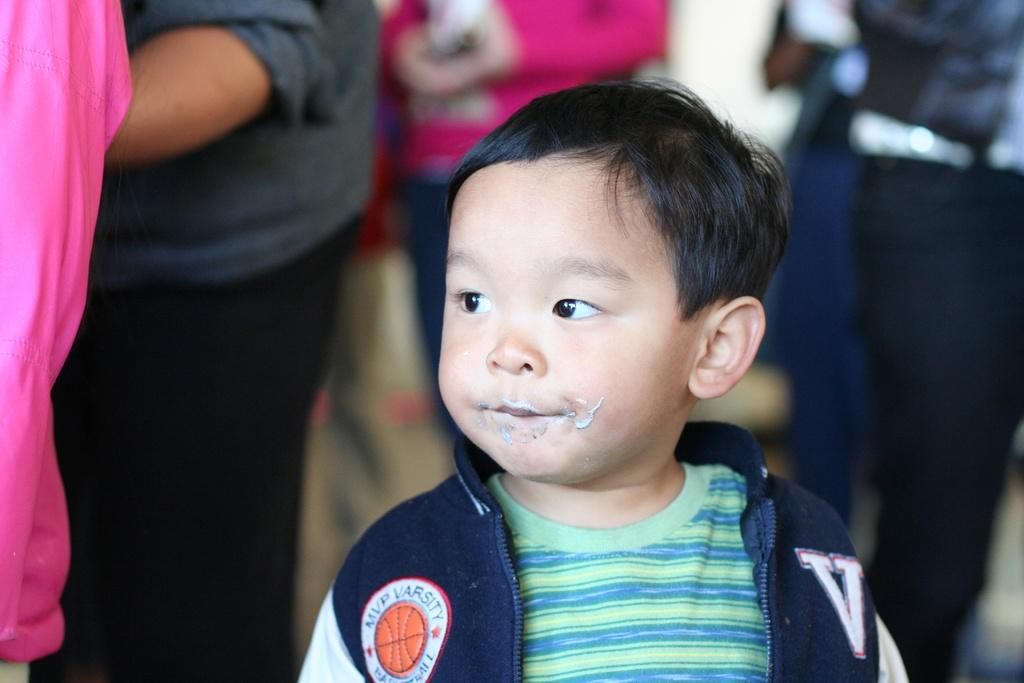<image>
Share a concise interpretation of the image provided. A young boy wears a jacket with an MVP VARSITY BASKETBALL patch on the front. 